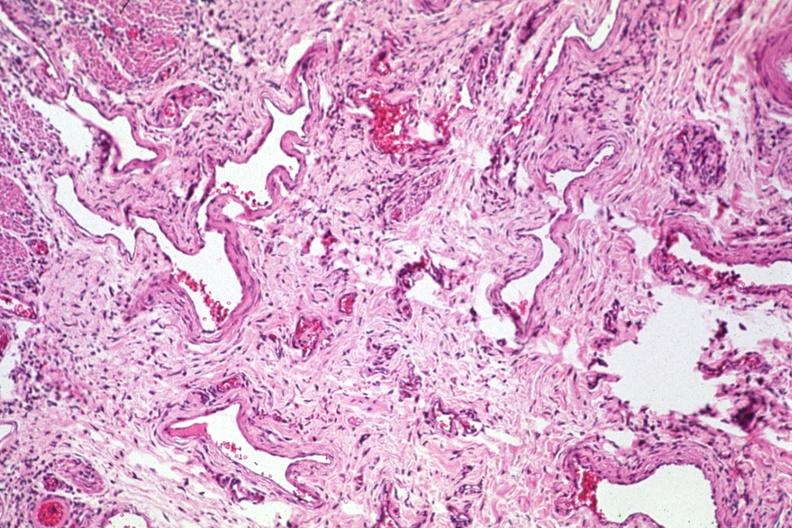where is this from?
Answer the question using a single word or phrase. Gastrointestinal system 